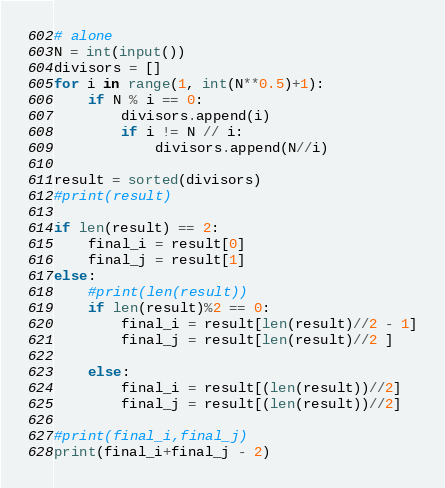Convert code to text. <code><loc_0><loc_0><loc_500><loc_500><_Python_># alone
N = int(input())
divisors = []
for i in range(1, int(N**0.5)+1):
    if N % i == 0:
        divisors.append(i)
        if i != N // i:
            divisors.append(N//i)

result = sorted(divisors)
#print(result)

if len(result) == 2:
    final_i = result[0]
    final_j = result[1]
else:
    #print(len(result))
    if len(result)%2 == 0:
        final_i = result[len(result)//2 - 1]
        final_j = result[len(result)//2 ]
            
    else:
        final_i = result[(len(result))//2]
        final_j = result[(len(result))//2]
            
#print(final_i,final_j)        
print(final_i+final_j - 2)</code> 